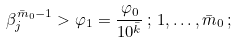Convert formula to latex. <formula><loc_0><loc_0><loc_500><loc_500>\beta ^ { \bar { m } _ { 0 } - 1 } _ { j } > \varphi _ { 1 } = \frac { \varphi _ { 0 } } { 1 0 ^ { \bar { k } } } \, ; \, 1 , \dots , \bar { m } _ { 0 } \, ;</formula> 